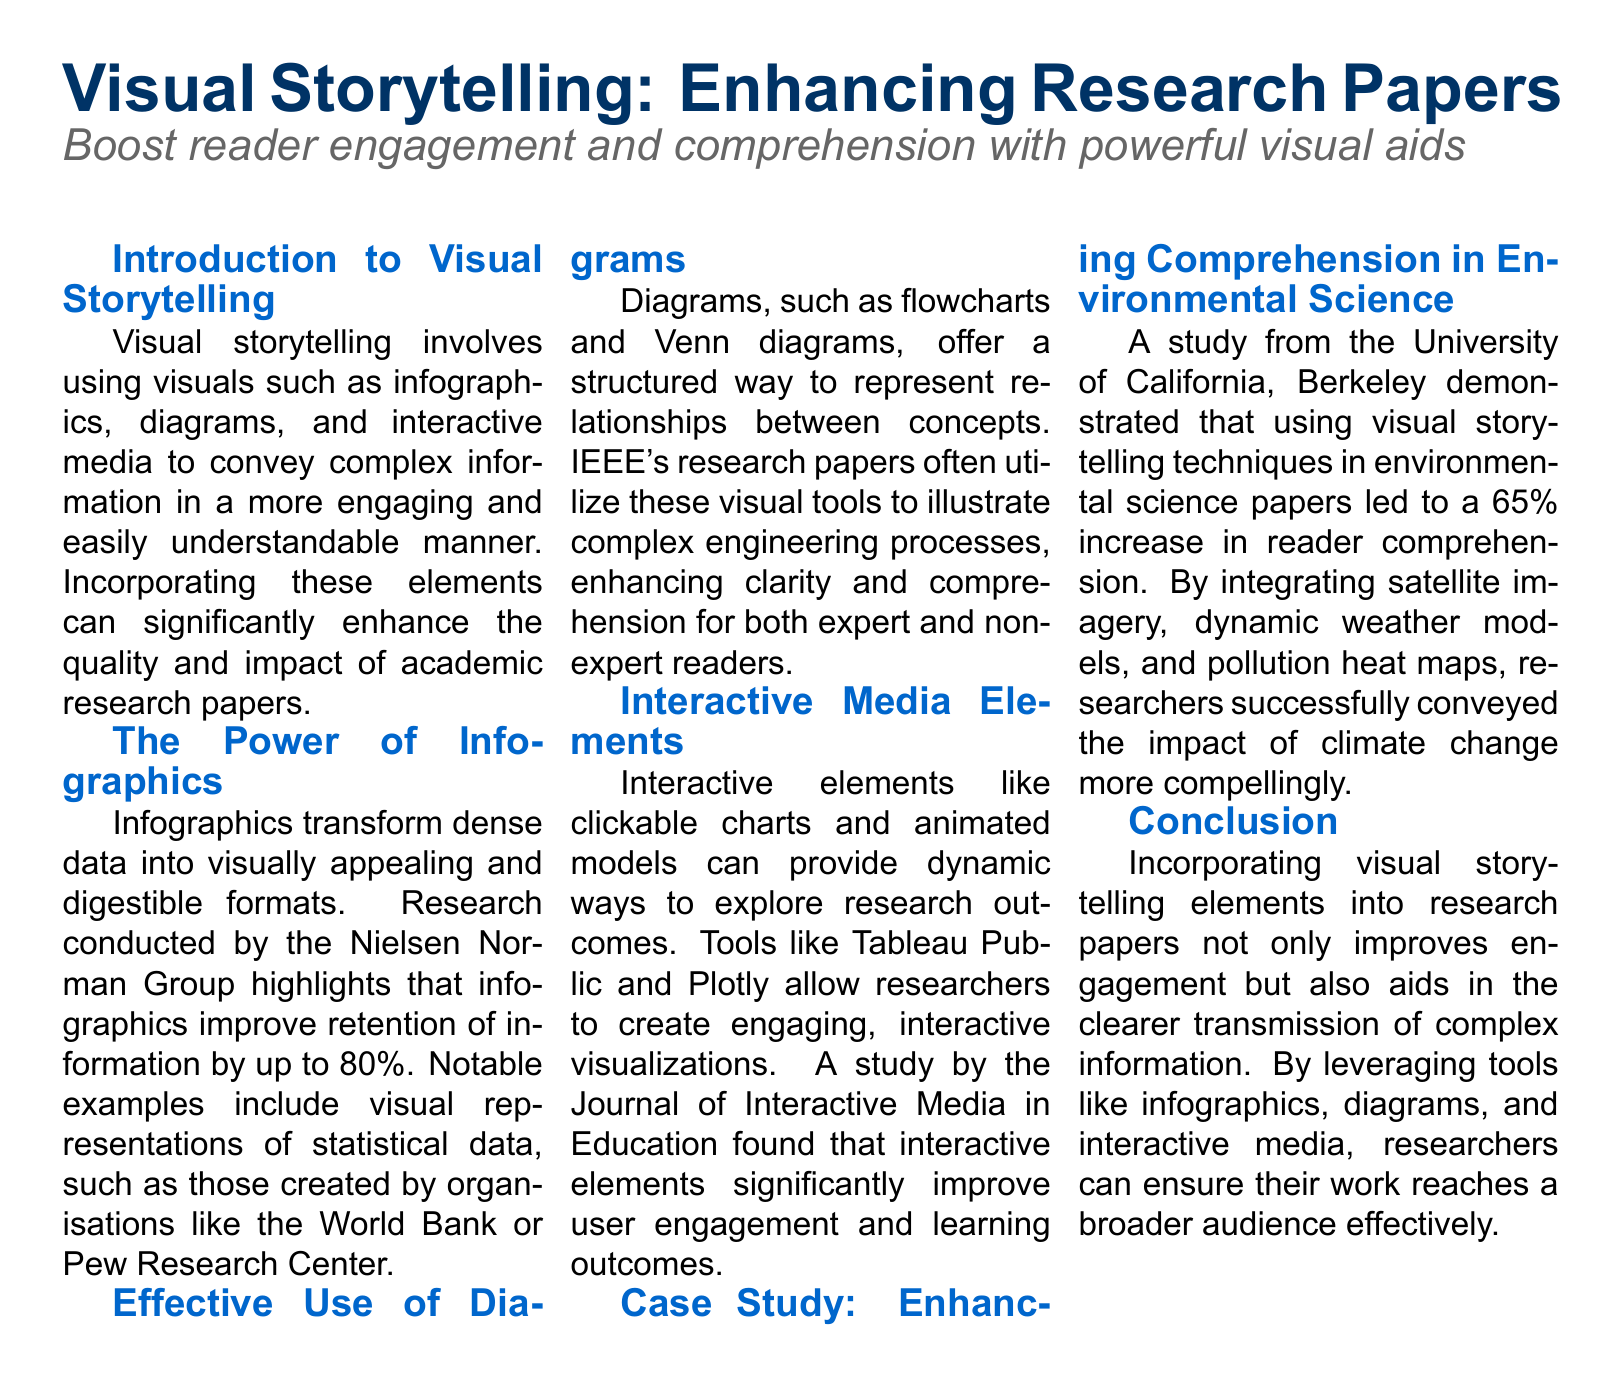what is the title of the document? The title is highlighted at the beginning of the document and summarizes the main topic.
Answer: Visual Storytelling: Enhancing Research Papers what element improves retention of information by up to 80 percent? The document cites research indicating a specific type of visual aid that enhances retention.
Answer: Infographics which university conducted a case study on visual storytelling in environmental science? The document mentions a specific university that conducted a study relevant to the topic.
Answer: University of California, Berkeley what percentage increase in reader comprehension was observed in the case study? This figure shows the impact of visual storytelling on comprehension as identified in the case study.
Answer: 65 percent name one tool mentioned for creating interactive visualizations. The document lists several tools for visual storytelling and interactivity.
Answer: Tableau Public what is an example of a diagram mentioned in the document? The document provides examples of visual tools used to convey complex relationships.
Answer: Venn diagrams which organization is cited for improving retention through infographics? This organization is mentioned as a reference for the effectiveness of infographics in research.
Answer: Nielsen Norman Group how can visual storytelling impact the audience's engagement according to the document? The document discusses the importance of visuals for enhancing engagement in research papers.
Answer: Improve engagement 